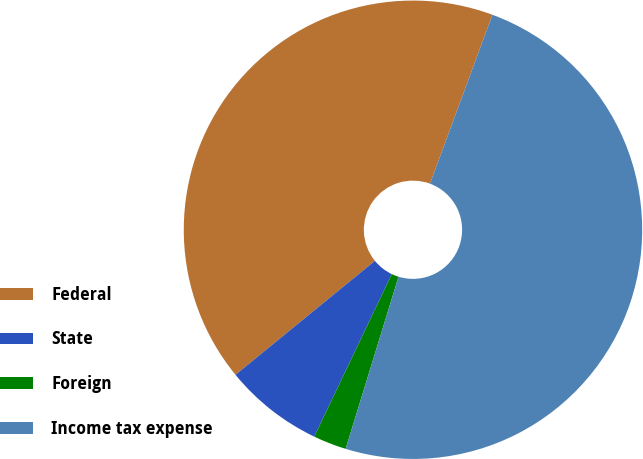<chart> <loc_0><loc_0><loc_500><loc_500><pie_chart><fcel>Federal<fcel>State<fcel>Foreign<fcel>Income tax expense<nl><fcel>41.54%<fcel>7.01%<fcel>2.34%<fcel>49.11%<nl></chart> 